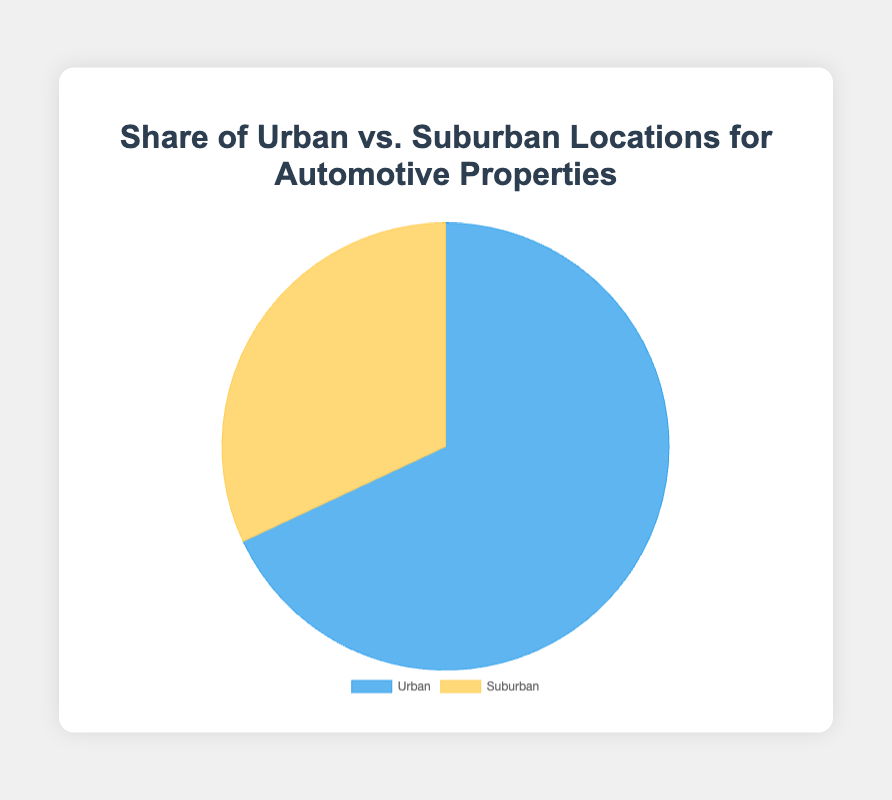what percentage of automotive properties are in urban locations? The pie chart shows the total number of properties in urban and suburban locations. We know that the total number of urban properties is 100 (derived from summing up all urban location values), and the total number of suburban properties is 47. Hence, the total number of properties is 147. The percentage of urban properties is (100/147) * 100% = 68%
Answer: 68% Which type of location, urban or suburban, has the higher share of automotive properties? The pie chart distinguishes between urban and suburban locations using different colors. The larger slice of the pie chart represents urban locations, indicating that urban has the higher share of automotive properties.
Answer: urban What is the total number of automotive properties considered in the chart? By summing up the total number of urban and suburban properties (100 and 47 respectively), we get the total number of automotive properties, which is 100 + 47 = 147
Answer: 147 How much greater is the number of urban properties compared to suburban properties? The number of urban properties is 100 and the number of suburban properties is 47. The difference between them is 100 - 47 = 53
Answer: 53 If two more properties are added to suburban areas, what would be the new percentage share of suburban locations? The new number of suburban properties would be 47 + 2 = 49. The total number of properties would be 100 (urban) + 49 (suburban) = 149. The new percentage of suburban properties would be (49/149) * 100% = 32.9%
Answer: 32.9% What is the ratio of urban to suburban properties? The number of urban properties is 100 and the number of suburban properties is 47. The ratio of urban to suburban properties is 100:47
Answer: 100:47 Which slice in the pie chart is larger and what does it represent? The larger slice in the pie chart represents urban locations. This can be inferred because the number of urban properties (100) is higher compared to suburban properties (47).
Answer: urban locations What color represents suburban locations in the pie chart? The pie chart uses a distinct color for suburban locations. According to the code, suburban locations are represented by yellow.
Answer: yellow 